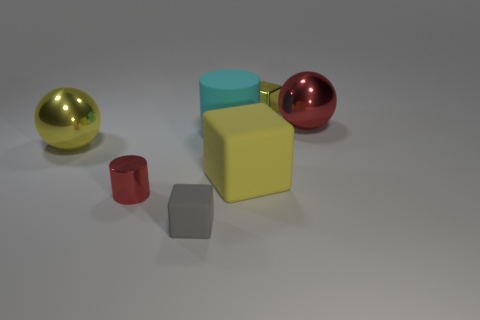There is a large shiny object that is the same color as the large matte block; what shape is it?
Your answer should be compact. Sphere. Are the small cube behind the large red thing and the red sphere made of the same material?
Ensure brevity in your answer.  Yes. What is the size of the yellow cube on the left side of the small metallic block?
Give a very brief answer. Large. There is a large thing that is left of the gray cube; is there a yellow metal ball that is behind it?
Your response must be concise. No. There is a big thing that is in front of the large yellow metallic object; does it have the same color as the big thing left of the tiny gray matte cube?
Give a very brief answer. Yes. The large cylinder is what color?
Your response must be concise. Cyan. Is there anything else that has the same color as the metal cube?
Provide a short and direct response. Yes. What is the color of the matte object that is to the left of the big block and behind the gray block?
Make the answer very short. Cyan. There is a rubber object in front of the red shiny cylinder; is its size the same as the big matte cylinder?
Ensure brevity in your answer.  No. Are there more gray blocks in front of the small red metal cylinder than big brown matte cylinders?
Offer a terse response. Yes. 